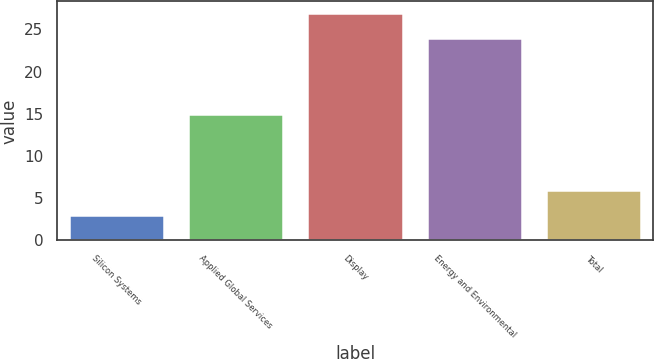<chart> <loc_0><loc_0><loc_500><loc_500><bar_chart><fcel>Silicon Systems<fcel>Applied Global Services<fcel>Display<fcel>Energy and Environmental<fcel>Total<nl><fcel>3<fcel>15<fcel>27<fcel>24<fcel>6<nl></chart> 